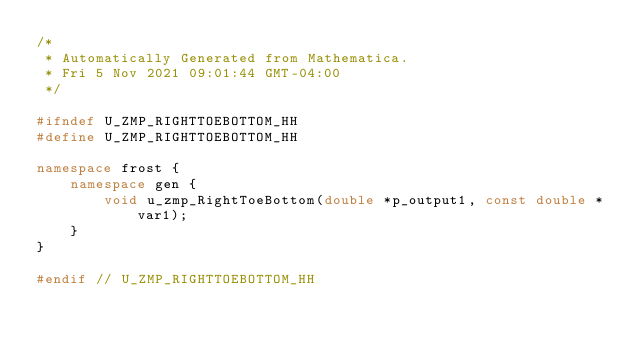Convert code to text. <code><loc_0><loc_0><loc_500><loc_500><_C++_>/*
 * Automatically Generated from Mathematica.
 * Fri 5 Nov 2021 09:01:44 GMT-04:00
 */

#ifndef U_ZMP_RIGHTTOEBOTTOM_HH
#define U_ZMP_RIGHTTOEBOTTOM_HH

namespace frost {
    namespace gen {
        void u_zmp_RightToeBottom(double *p_output1, const double *var1);
    }
}

#endif // U_ZMP_RIGHTTOEBOTTOM_HH
</code> 